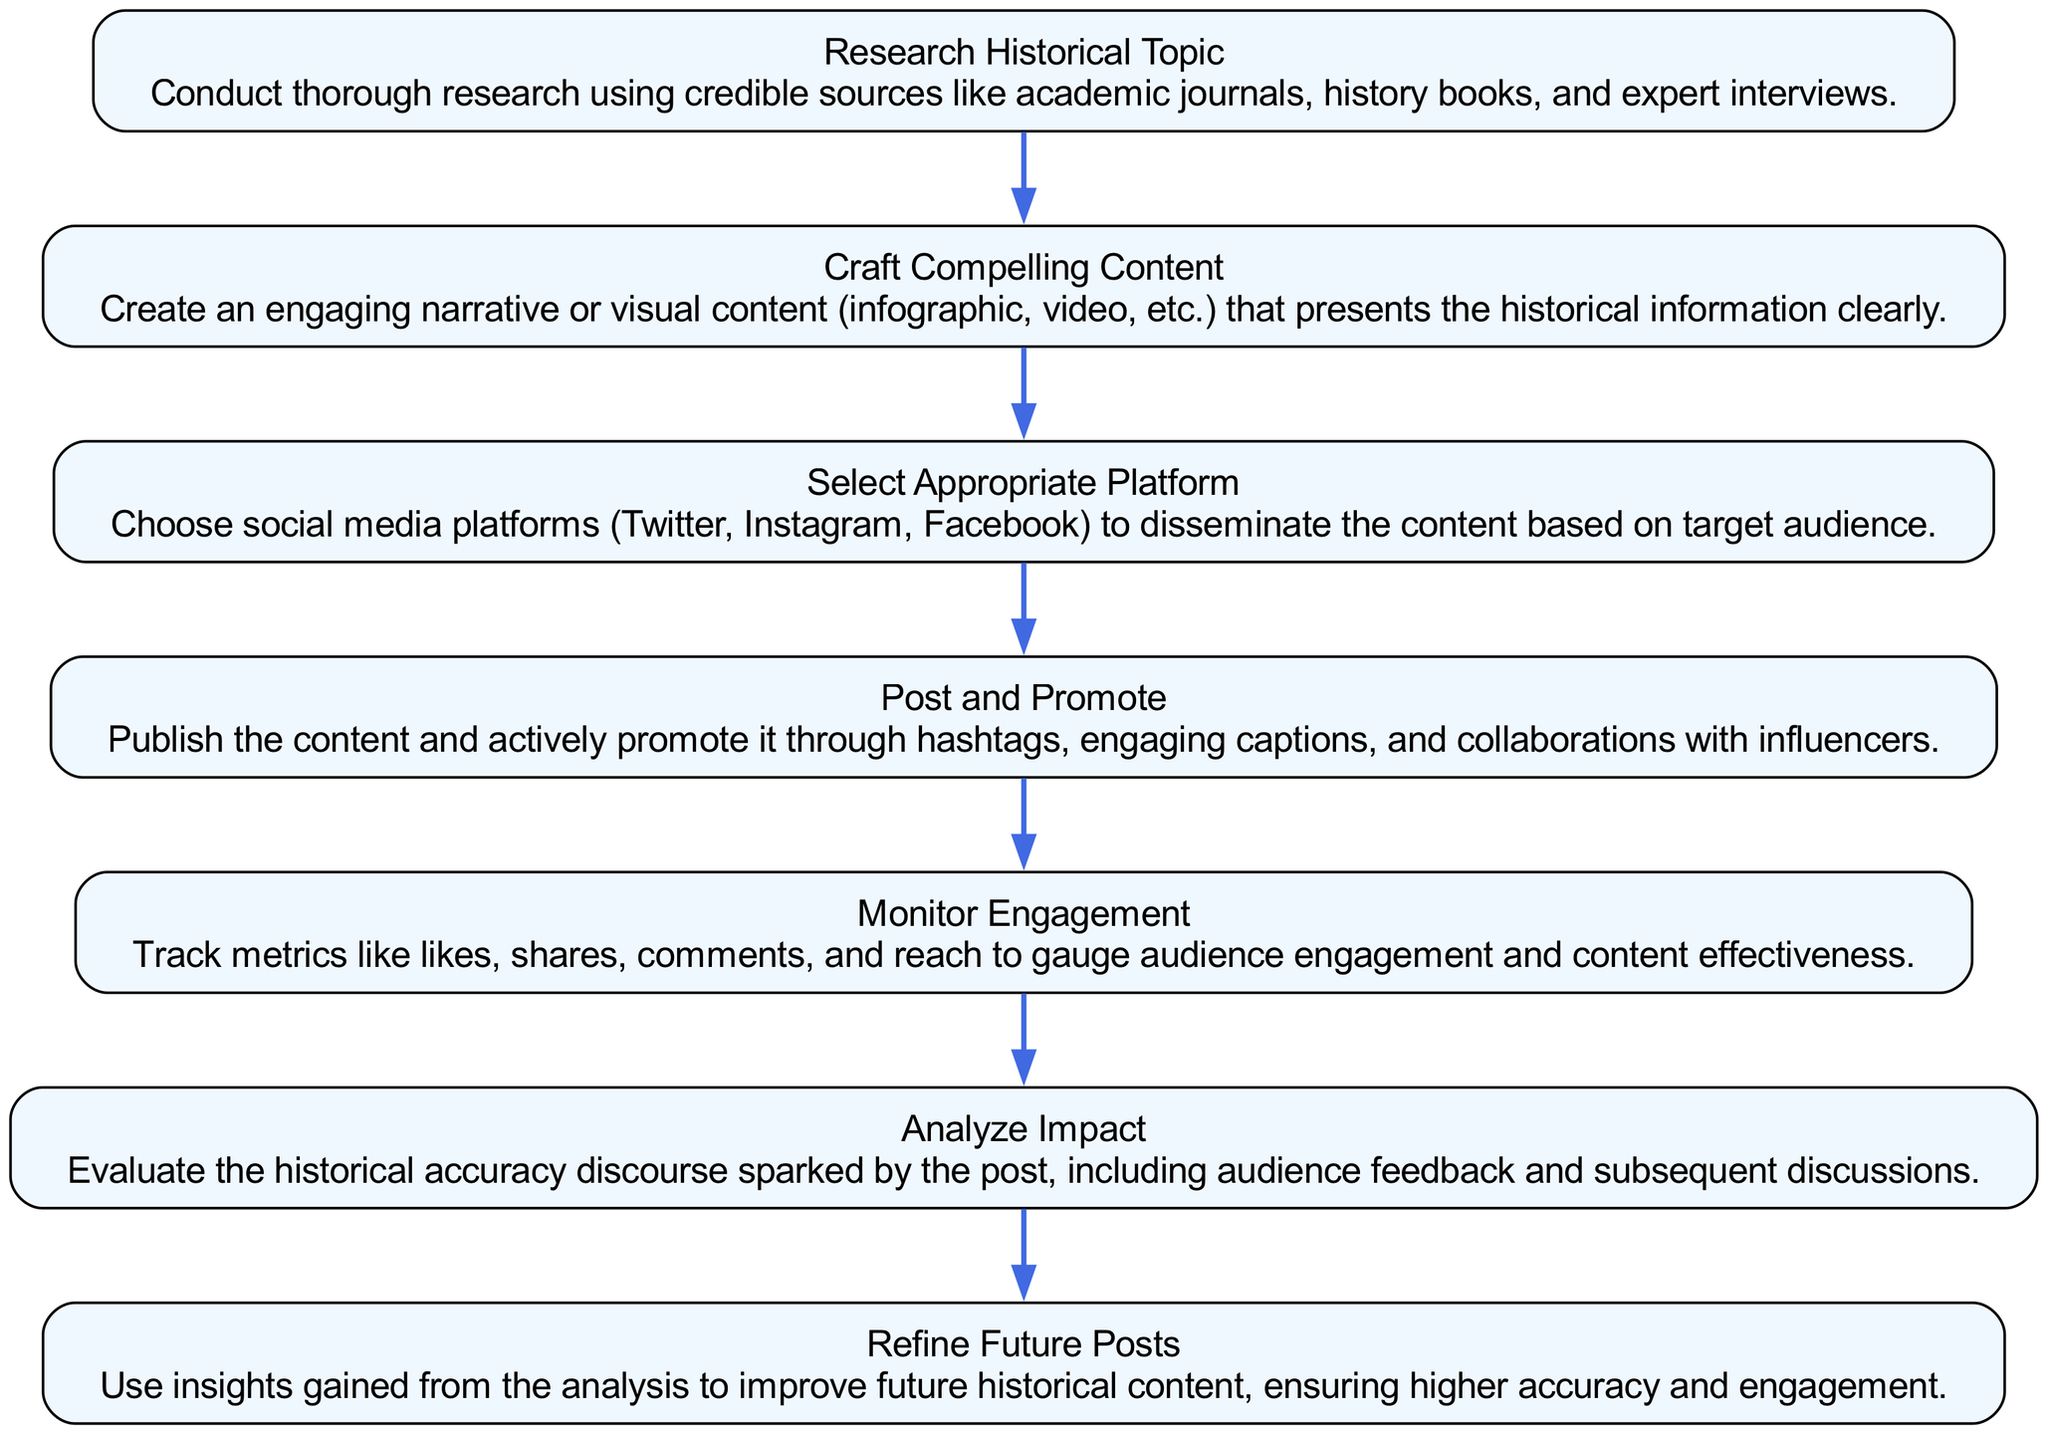What is the first step in the journey of a viral historical post? The first step in the flow chart is "Research Historical Topic." This node is positioned at the top of the diagram, indicating it is the initial action to be taken before any further steps.
Answer: Research Historical Topic How many nodes are present in the diagram? The diagram contains a total of 7 nodes, which represent distinct steps in the journey of a viral historical post from creation to impact analysis. This can be counted visually by identifying each unique step represented in the flow.
Answer: 7 Which step follows "Craft Compelling Content"? The step that follows "Craft Compelling Content" in the flow chart is "Select Appropriate Platform." This relationship can be determined by observing the directional arrows that indicate the flow from one step to the next.
Answer: Select Appropriate Platform What does the "Analyze Impact" step evaluate? The "Analyze Impact" step evaluates the historical accuracy discourse sparked by the post and includes audience feedback and subsequent discussions. This understanding combines insights from the node description and its placement in the flow, indicating the analytical phase of the process.
Answer: Historical accuracy discourse What is the final step in the journey of a viral historical post? The final step in the flow chart is "Refine Future Posts." This node is at the bottom of the diagram, indicating it is the last action taken after analyzing the impact of previous content.
Answer: Refine Future Posts Which two steps involve audience interaction? The two steps that involve audience interaction are "Post and Promote" and "Monitor Engagement." "Post and Promote" focuses on publishing the content, while "Monitor Engagement" specifically looks at audience metrics and feedback following the post. Both are critical steps that directly engage with the audience.
Answer: Post and Promote, Monitor Engagement What flow does the diagram follow? The flow of the diagram follows a linear progression from top to bottom, starting with research and ending with refining future posts. Each step leads sequentially into the next, indicating a clear path in the process.
Answer: Top to bottom What is the main purpose of the "Monitor Engagement" step? The main purpose of the "Monitor Engagement" step is to track metrics like likes, shares, comments, and reach to gauge audience engagement and content effectiveness. This understanding can be derived from the description within the node itself, outlining the evaluation aspect of this step.
Answer: Track audience engagement 